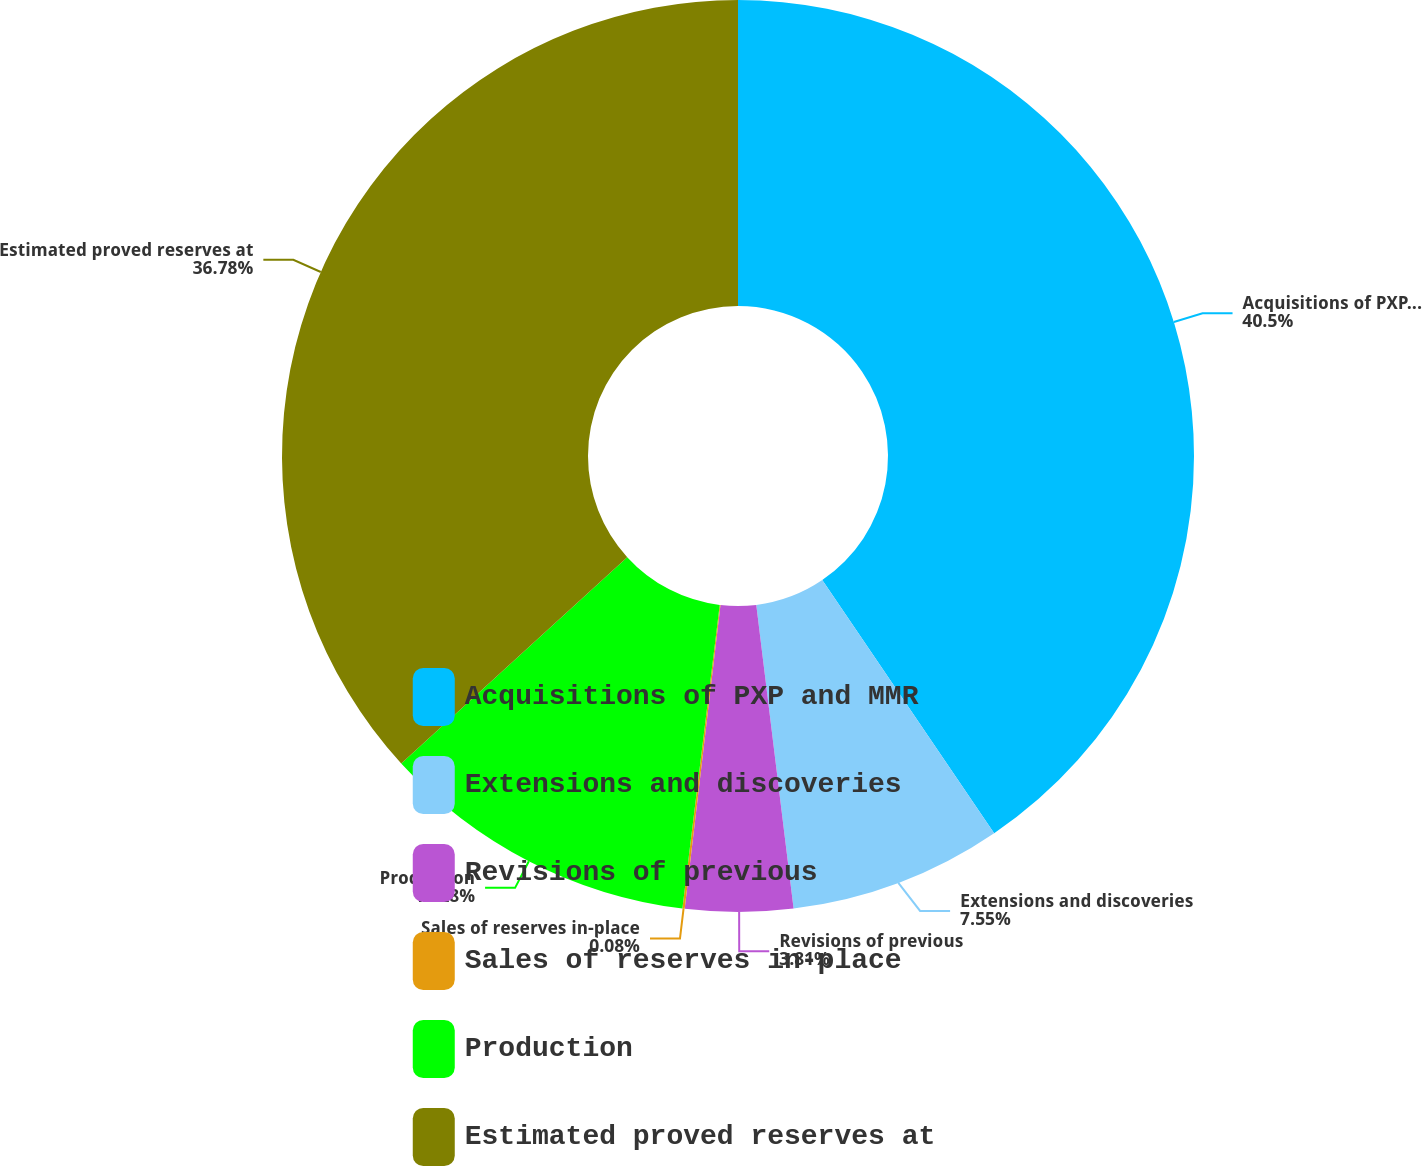<chart> <loc_0><loc_0><loc_500><loc_500><pie_chart><fcel>Acquisitions of PXP and MMR<fcel>Extensions and discoveries<fcel>Revisions of previous<fcel>Sales of reserves in-place<fcel>Production<fcel>Estimated proved reserves at<nl><fcel>40.51%<fcel>7.55%<fcel>3.81%<fcel>0.08%<fcel>11.28%<fcel>36.78%<nl></chart> 